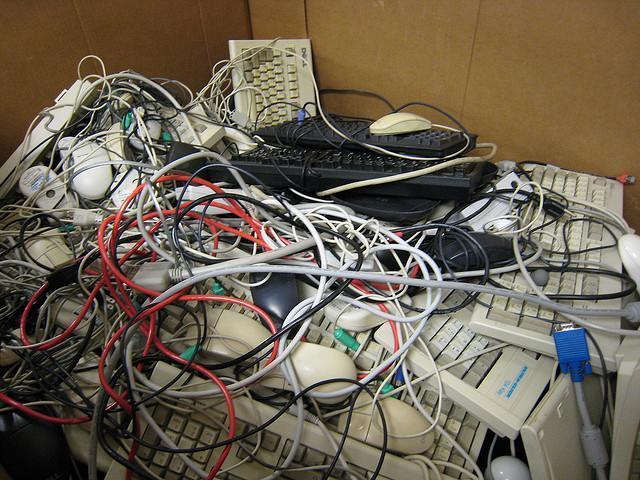How many keyboards can you see?
Give a very brief answer. 11. How many mice are in the photo?
Give a very brief answer. 5. How many motor vehicles have orange paint?
Give a very brief answer. 0. 